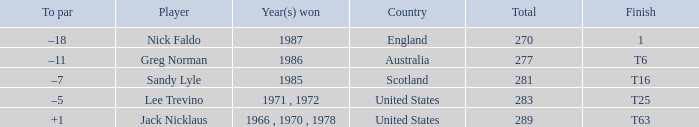What player has 1 as the place? Nick Faldo. 